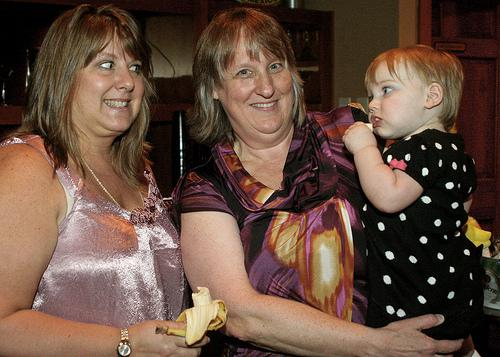Question: who is in the photo?
Choices:
A. Children waving.
B. Two ladies and a toddler.
C. Animals eating.
D. Chickens crowing.
Answer with the letter. Answer: B Question: who is the lady on the right holding?
Choices:
A. Her husband.
B. Her grandchild.
C. A toddler.
D. Her daughter.
Answer with the letter. Answer: C Question: why are the ladies smiling?
Choices:
A. They is happy.
B. The toddler is cute.
C. They is posing for picture.
D. They are joking around.
Answer with the letter. Answer: B Question: how is the toddler dressed?
Choices:
A. In all pink.
B. In a jumper.
C. In all blue.
D. In black with white polka dots.
Answer with the letter. Answer: D Question: what does the lady on the left have on her wrist?
Choices:
A. A bracelet.
B. A charme.
C. A watch.
D. Her keyband.
Answer with the letter. Answer: C 